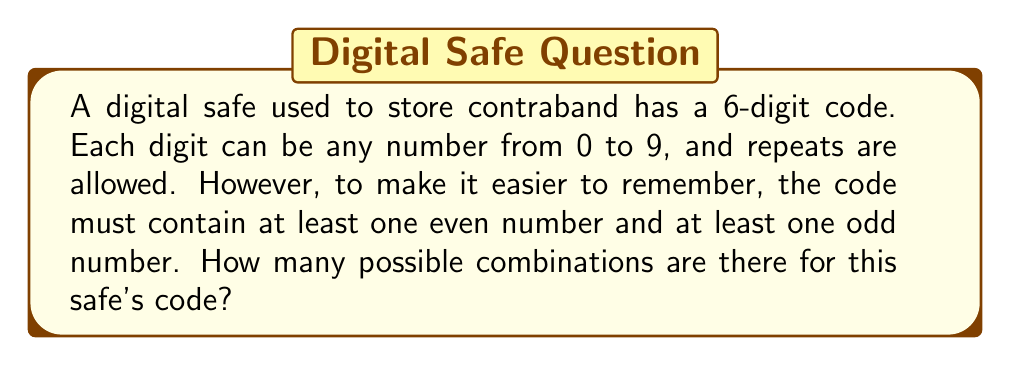Teach me how to tackle this problem. Let's approach this step-by-step:

1) First, let's calculate the total number of 6-digit codes without any restrictions:
   $$10^6 = 1,000,000$$

2) Now, we need to subtract the number of codes that don't meet our criteria. These would be:
   a) Codes with all even numbers
   b) Codes with all odd numbers

3) For all even numbers:
   We have 5 even digits (0, 2, 4, 6, 8) to choose from for each of the 6 positions:
   $$5^6 = 15,625$$

4) For all odd numbers:
   We have 5 odd digits (1, 3, 5, 7, 9) to choose from for each of the 6 positions:
   $$5^6 = 15,625$$

5) Therefore, the number of valid combinations is:
   $$\text{Total} - \text{All Even} - \text{All Odd}$$
   $$1,000,000 - 15,625 - 15,625 = 968,750$$
Answer: 968,750 